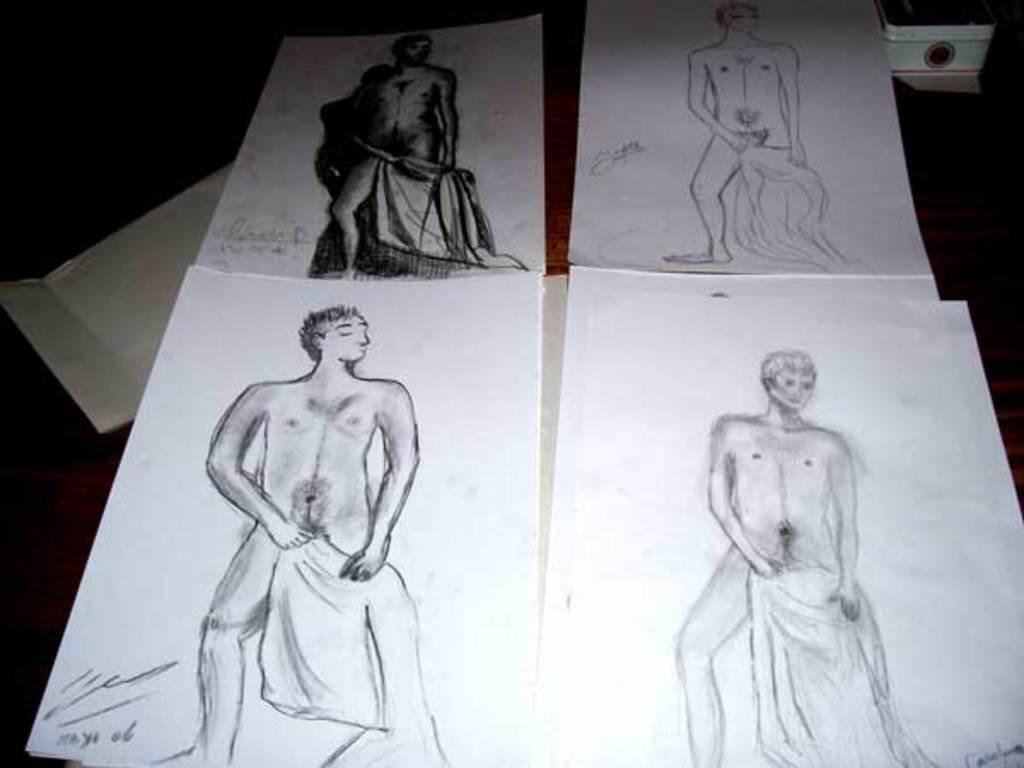What is depicted on the papers that are on the table? There are pictures of a man on the papers. Where are the papers with the pictures located? The papers are placed on a table. What type of operation is being performed on the man in the image? There is no operation being performed on the man in the image; it is a picture on a paper. What kind of rod is used to create the pictures of the man on the papers? There is no rod used to create the pictures of the man on the papers; they are likely printed or drawn. 